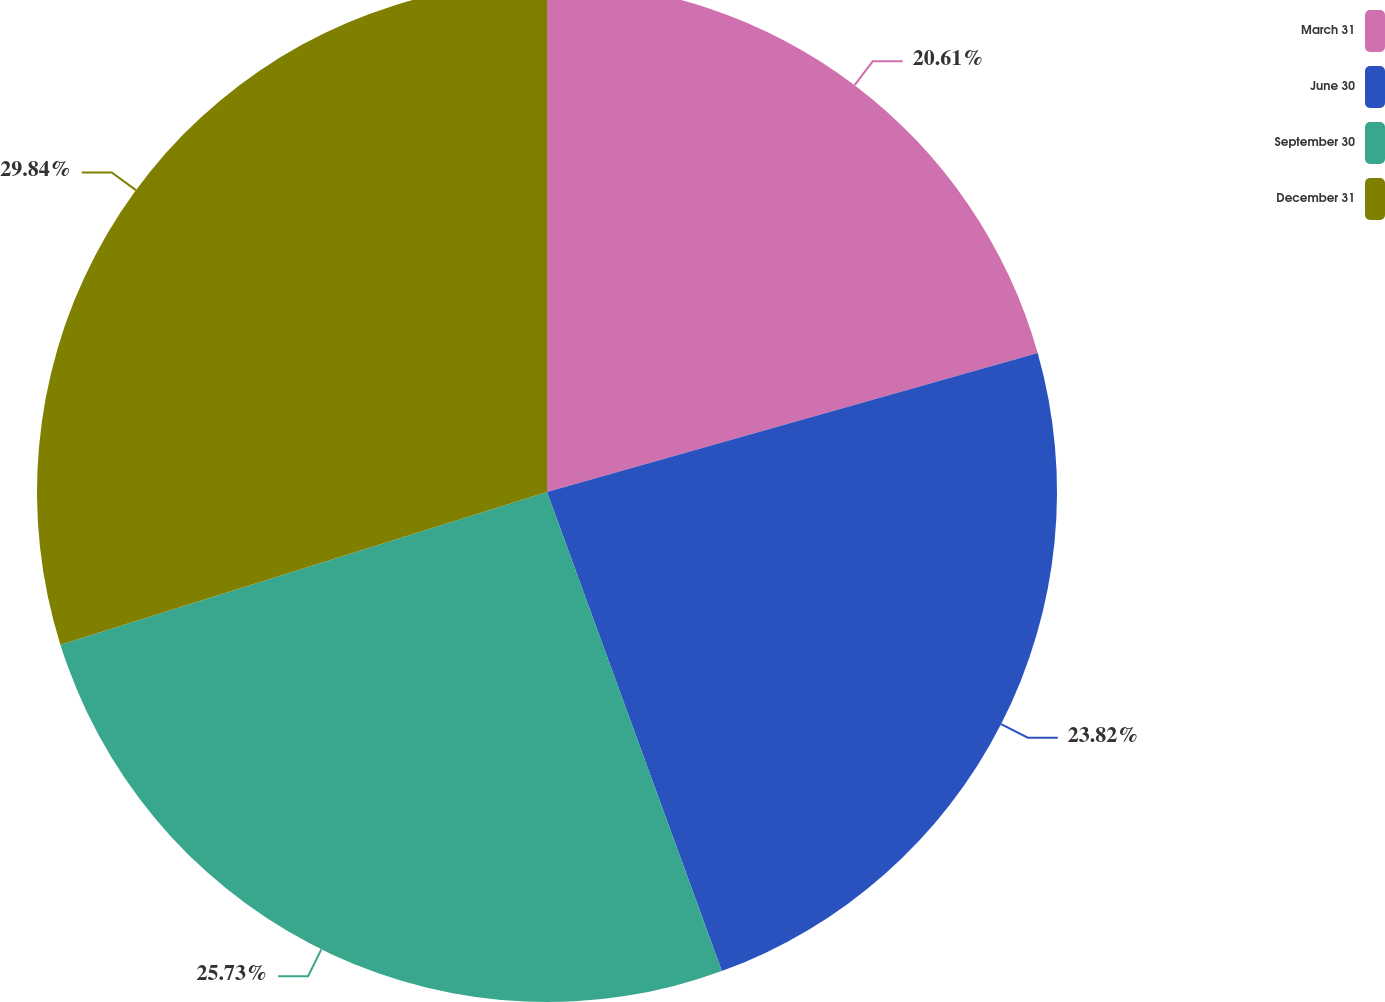<chart> <loc_0><loc_0><loc_500><loc_500><pie_chart><fcel>March 31<fcel>June 30<fcel>September 30<fcel>December 31<nl><fcel>20.61%<fcel>23.82%<fcel>25.73%<fcel>29.84%<nl></chart> 